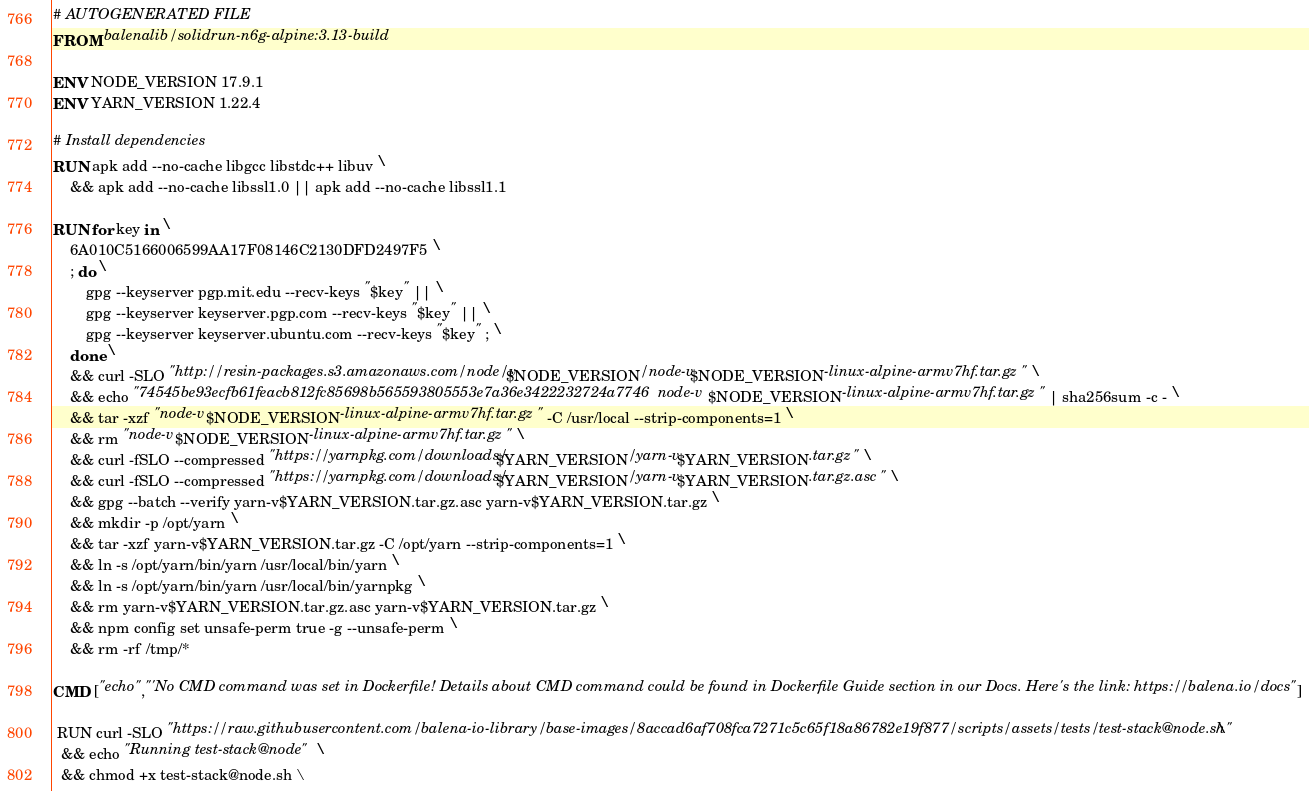Convert code to text. <code><loc_0><loc_0><loc_500><loc_500><_Dockerfile_># AUTOGENERATED FILE
FROM balenalib/solidrun-n6g-alpine:3.13-build

ENV NODE_VERSION 17.9.1
ENV YARN_VERSION 1.22.4

# Install dependencies
RUN apk add --no-cache libgcc libstdc++ libuv \
	&& apk add --no-cache libssl1.0 || apk add --no-cache libssl1.1

RUN for key in \
	6A010C5166006599AA17F08146C2130DFD2497F5 \
	; do \
		gpg --keyserver pgp.mit.edu --recv-keys "$key" || \
		gpg --keyserver keyserver.pgp.com --recv-keys "$key" || \
		gpg --keyserver keyserver.ubuntu.com --recv-keys "$key" ; \
	done \
	&& curl -SLO "http://resin-packages.s3.amazonaws.com/node/v$NODE_VERSION/node-v$NODE_VERSION-linux-alpine-armv7hf.tar.gz" \
	&& echo "74545be93ecfb61feacb812fc85698b565593805553e7a36e3422232724a7746  node-v$NODE_VERSION-linux-alpine-armv7hf.tar.gz" | sha256sum -c - \
	&& tar -xzf "node-v$NODE_VERSION-linux-alpine-armv7hf.tar.gz" -C /usr/local --strip-components=1 \
	&& rm "node-v$NODE_VERSION-linux-alpine-armv7hf.tar.gz" \
	&& curl -fSLO --compressed "https://yarnpkg.com/downloads/$YARN_VERSION/yarn-v$YARN_VERSION.tar.gz" \
	&& curl -fSLO --compressed "https://yarnpkg.com/downloads/$YARN_VERSION/yarn-v$YARN_VERSION.tar.gz.asc" \
	&& gpg --batch --verify yarn-v$YARN_VERSION.tar.gz.asc yarn-v$YARN_VERSION.tar.gz \
	&& mkdir -p /opt/yarn \
	&& tar -xzf yarn-v$YARN_VERSION.tar.gz -C /opt/yarn --strip-components=1 \
	&& ln -s /opt/yarn/bin/yarn /usr/local/bin/yarn \
	&& ln -s /opt/yarn/bin/yarn /usr/local/bin/yarnpkg \
	&& rm yarn-v$YARN_VERSION.tar.gz.asc yarn-v$YARN_VERSION.tar.gz \
	&& npm config set unsafe-perm true -g --unsafe-perm \
	&& rm -rf /tmp/*

CMD ["echo","'No CMD command was set in Dockerfile! Details about CMD command could be found in Dockerfile Guide section in our Docs. Here's the link: https://balena.io/docs"]

 RUN curl -SLO "https://raw.githubusercontent.com/balena-io-library/base-images/8accad6af708fca7271c5c65f18a86782e19f877/scripts/assets/tests/test-stack@node.sh" \
  && echo "Running test-stack@node" \
  && chmod +x test-stack@node.sh \</code> 